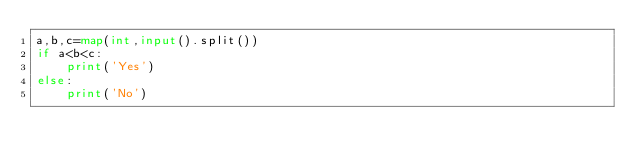<code> <loc_0><loc_0><loc_500><loc_500><_Python_>a,b,c=map(int,input().split())
if a<b<c:
    print('Yes')
else:
    print('No')
</code> 